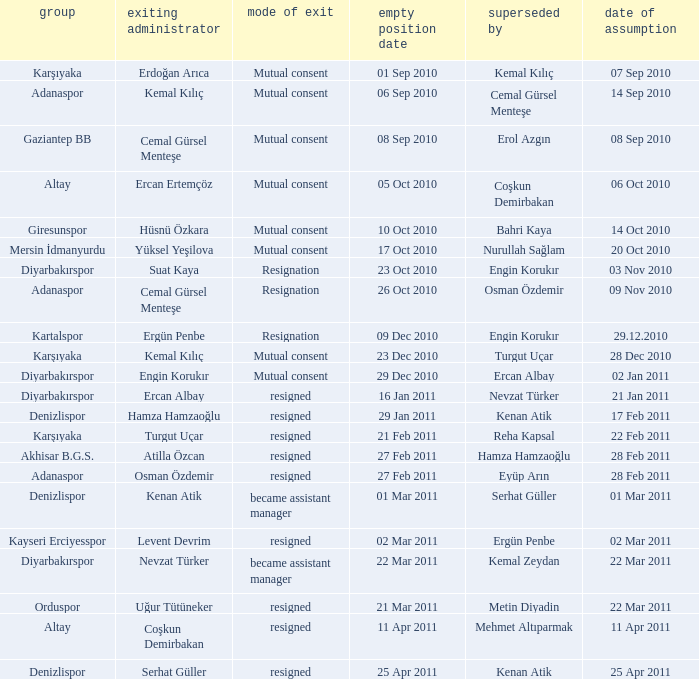Who replaced the manager of Akhisar B.G.S.? Hamza Hamzaoğlu. 